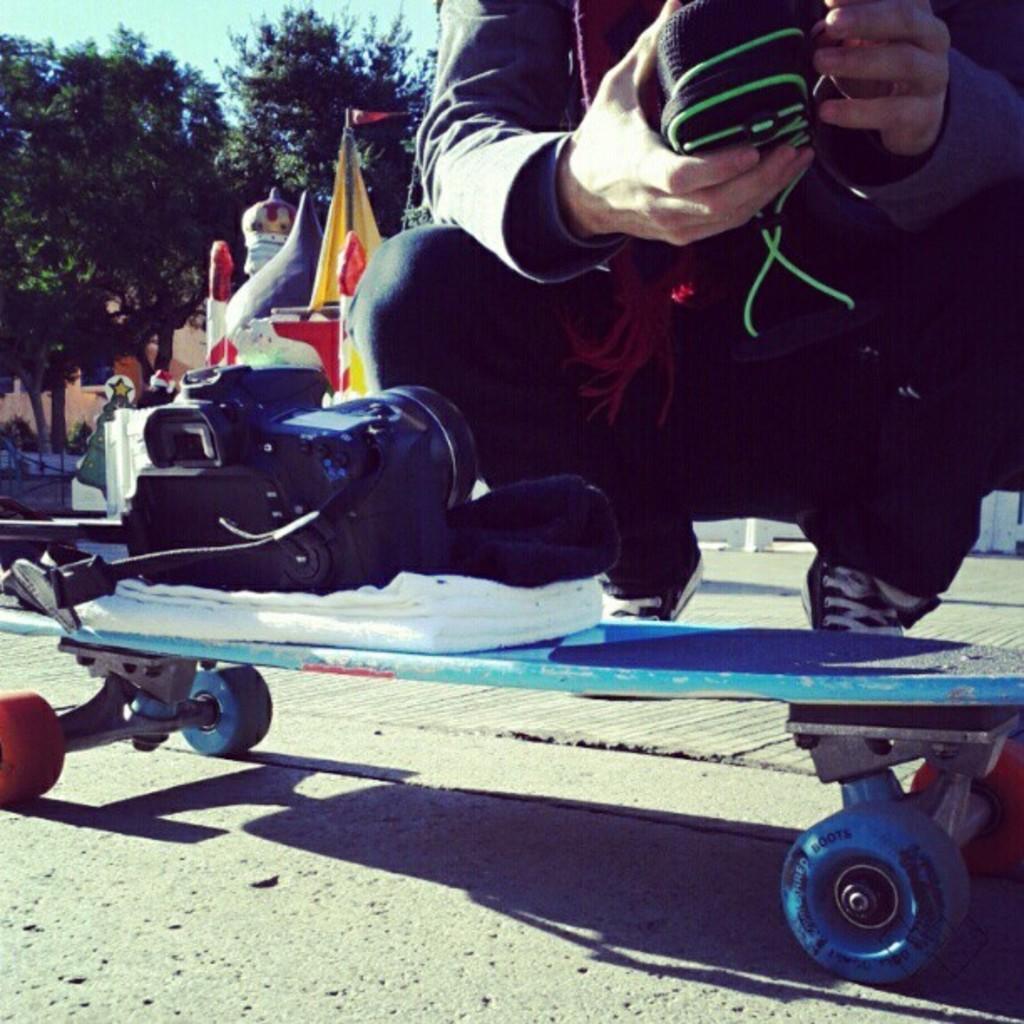Can you describe this image briefly? In this image there is a skateboard, on top of the skateboard there is a camera on the towel, beside the skateboard there is a person knelt down by holding a shoe in his hand, behind the person there are a few objects, in the background of the image there are trees and buildings. 